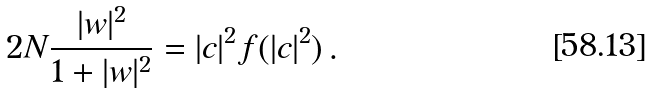Convert formula to latex. <formula><loc_0><loc_0><loc_500><loc_500>2 N \frac { | w | ^ { 2 } } { 1 + | w | ^ { 2 } } = | c | ^ { 2 } f ( | c | ^ { 2 } ) \, .</formula> 